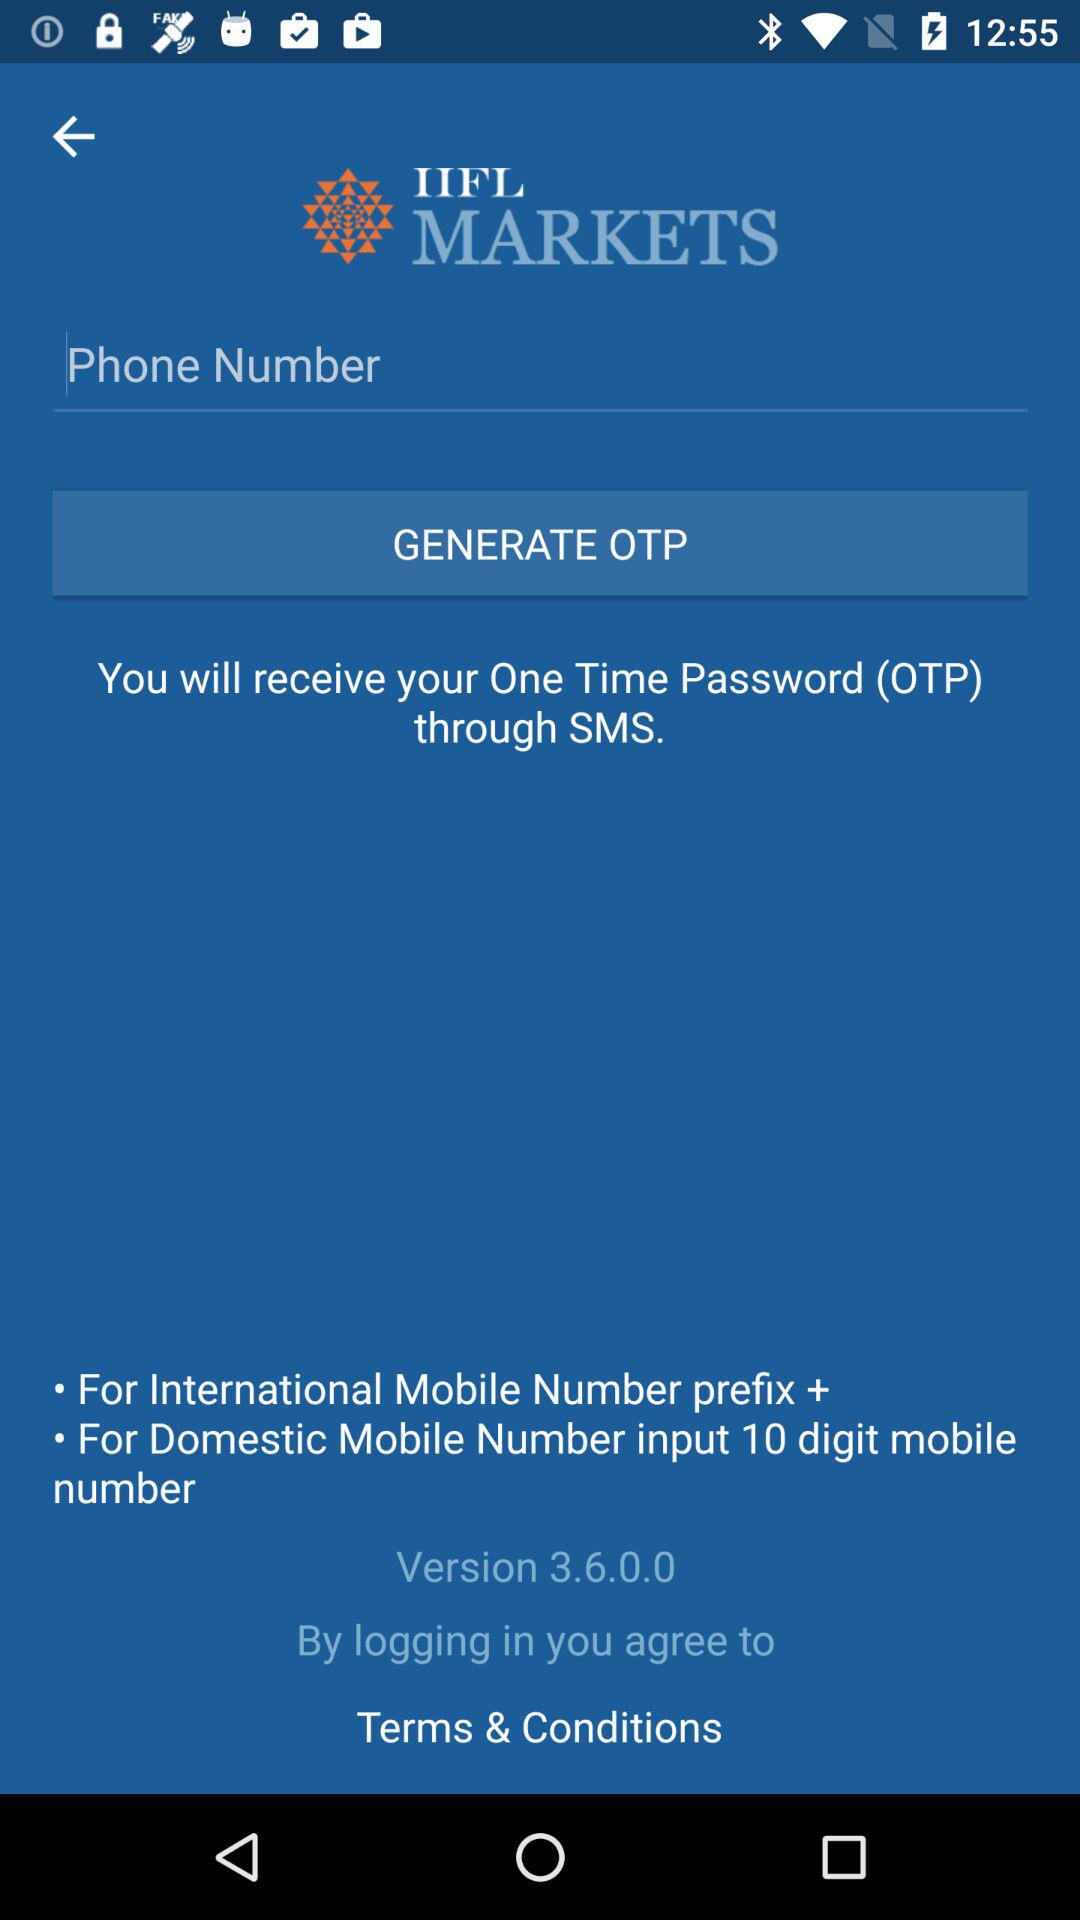What is the full form of OTP? The full form of OTP is One Time Password. 